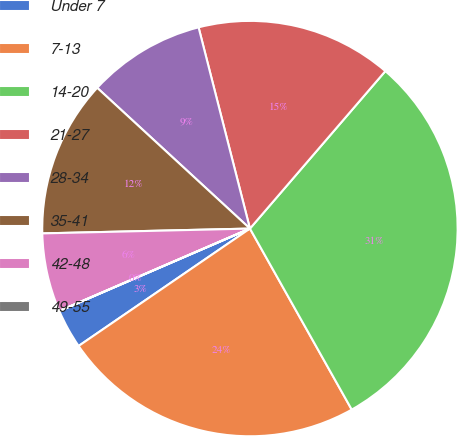Convert chart to OTSL. <chart><loc_0><loc_0><loc_500><loc_500><pie_chart><fcel>Under 7<fcel>7-13<fcel>14-20<fcel>21-27<fcel>28-34<fcel>35-41<fcel>42-48<fcel>49-55<nl><fcel>3.06%<fcel>23.59%<fcel>30.54%<fcel>15.28%<fcel>9.17%<fcel>12.22%<fcel>6.12%<fcel>0.01%<nl></chart> 